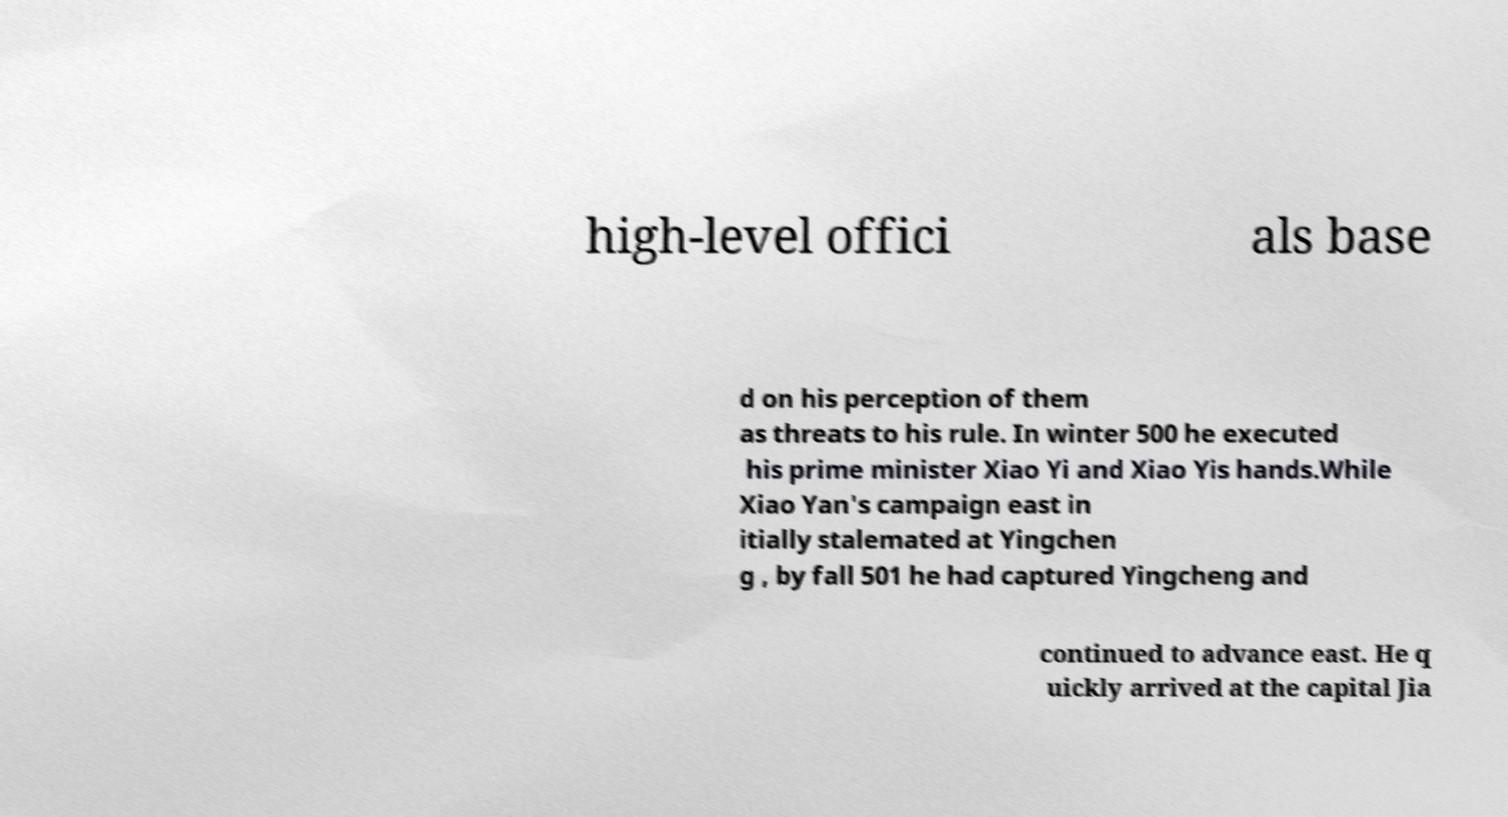For documentation purposes, I need the text within this image transcribed. Could you provide that? high-level offici als base d on his perception of them as threats to his rule. In winter 500 he executed his prime minister Xiao Yi and Xiao Yis hands.While Xiao Yan's campaign east in itially stalemated at Yingchen g , by fall 501 he had captured Yingcheng and continued to advance east. He q uickly arrived at the capital Jia 